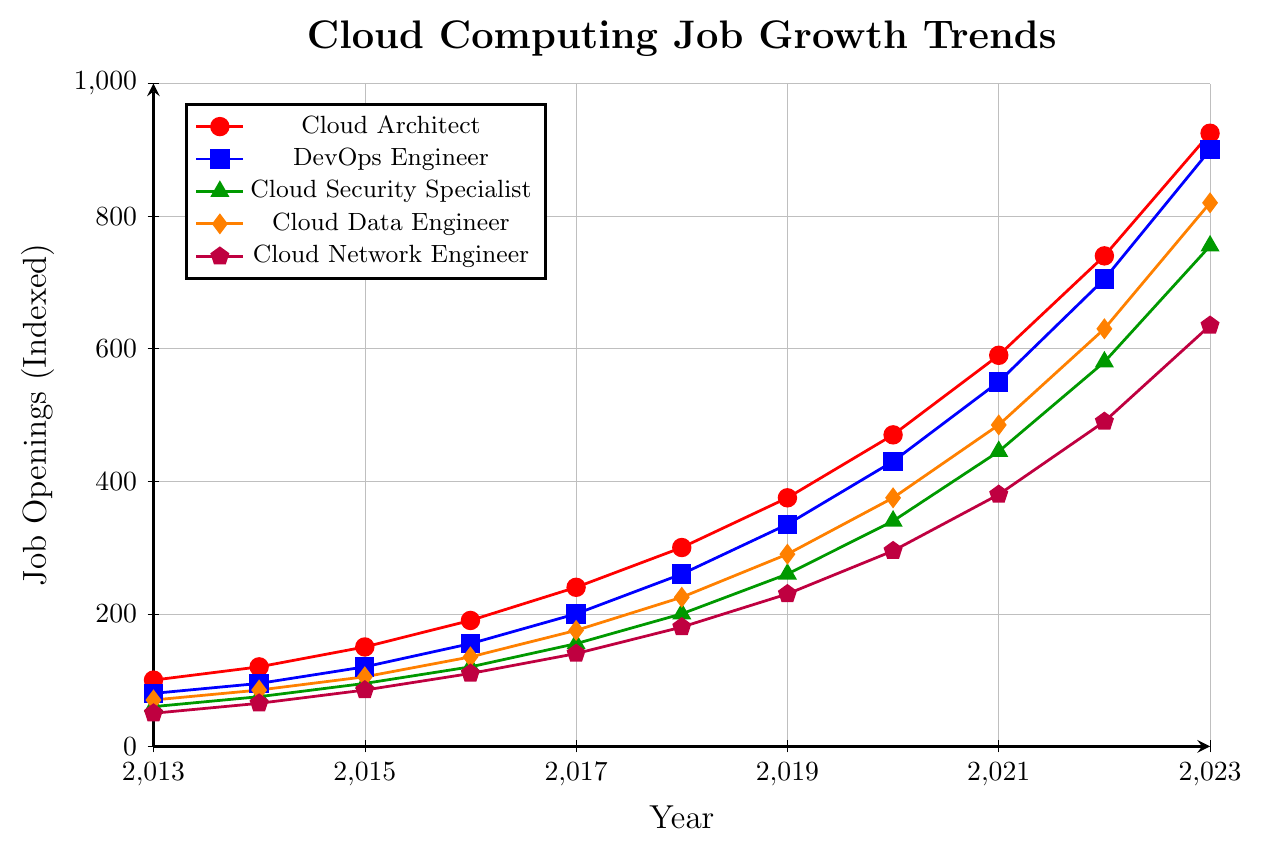What was the job growth trend for Cloud Architects from 2013 to 2023? The red line in the plot indicates the job openings for Cloud Architects. Starting from 100 in 2013, it shows a steady increase each year until reaching 925 in 2023.
Answer: Steady increase Which role had the highest job openings in 2023? The plot shows five roles, each marked with different colors. The highest point in 2023 is for the DevOps Engineer, represented by the blue line, reaching 900 job openings.
Answer: DevOps Engineer Between 2013 and 2023, which role experienced the largest growth in job openings? To find the largest growth, subtract the 2013 values from the 2023 values for each role:
- Cloud Architect: 925 - 100 = 825
- DevOps Engineer: 900 - 80 = 820
- Cloud Security Specialist: 755 - 60 = 695
- Cloud Data Engineer: 820 - 70 = 750
- Cloud Network Engineer: 635 - 50 = 585
The Cloud Architect experienced the largest growth of 825.
Answer: Cloud Architect What is the difference in job openings between Cloud Data Engineers and Cloud Network Engineers in 2023? Locate the points for both roles in 2023: Cloud Data Engineer (orange line) has 820 job openings, and Cloud Network Engineer (purple line) has 635 job openings. The difference is 820 - 635 = 185.
Answer: 185 Which role saw the smallest number of job openings in 2015? Refer to the 2015 data points for all roles:
- Cloud Architect: 150
- DevOps Engineer: 120
- Cloud Security Specialist: 95
- Cloud Data Engineer: 105
- Cloud Network Engineer: 85
The smallest number is 85 for Cloud Network Engineer.
Answer: Cloud Network Engineer What was the average number of job openings for DevOps Engineers from 2013 to 2015? Sum the job openings for DevOps Engineers in 2013 (80), 2014 (95), and 2015 (120), and divide by 3: (80 + 95 + 120) / 3 = 295 / 3 ≈ 98.33
Answer: 98.33 By how many job openings did the Cloud Security Specialist role grow between 2017 and 2019? Locate the points for the Cloud Security Specialist in 2017 (155) and 2019 (260). The growth is 260 - 155 = 105.
Answer: 105 What was the total number of job openings for all roles in 2020? Sum the values for each role in 2020:
- Cloud Architect: 470
- DevOps Engineer: 430
- Cloud Security Specialist: 340
- Cloud Data Engineer: 375
- Cloud Network Engineer: 295
The total is 470 + 430 + 340 + 375 + 295 = 1910.
Answer: 1910 Which role had consistent, steady growth with no years of stagnation or decline? Check the lines for each role to see if there are any dips or stagnant periods. The Cloud Architect (red line), DevOps Engineer (blue line), Cloud Security Specialist (green line), Cloud Data Engineer (orange line), and Cloud Network Engineer (purple line) all show consistent growth.
Answer: All roles Which two roles had the closest job openings in 2016? Compare the 2016 values:
- Cloud Architect: 190
- DevOps Engineer: 155
- Cloud Security Specialist: 120
- Cloud Data Engineer: 135
- Cloud Network Engineer: 110
The Cloud Data Engineer and Cloud Security Specialist have the closest values, 135 and 120, respectively.
Answer: Cloud Data Engineer and Cloud Security Specialist 